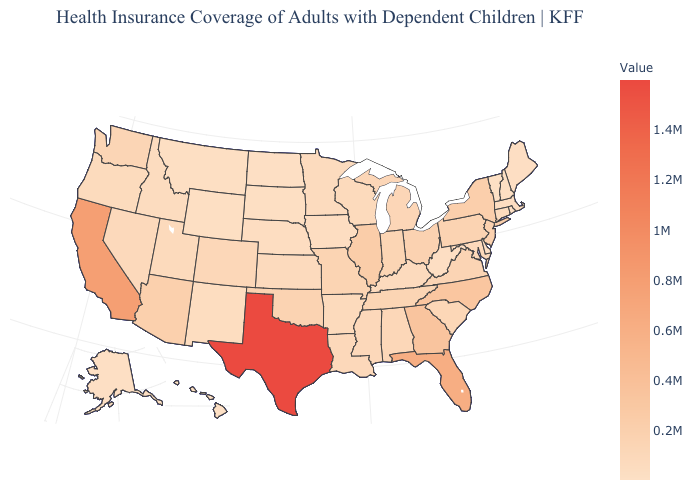Among the states that border North Dakota , which have the highest value?
Answer briefly. Minnesota. Does Texas have the highest value in the USA?
Keep it brief. Yes. Does the map have missing data?
Quick response, please. No. Among the states that border Ohio , does Pennsylvania have the highest value?
Quick response, please. Yes. 